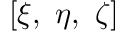Convert formula to latex. <formula><loc_0><loc_0><loc_500><loc_500>\left [ \xi , \ \eta , \ \zeta \right ]</formula> 